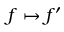<formula> <loc_0><loc_0><loc_500><loc_500>f \mapsto f ^ { \prime }</formula> 